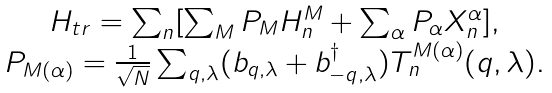<formula> <loc_0><loc_0><loc_500><loc_500>\begin{array} { c } H _ { t r } = \sum _ { n } [ \sum _ { M } P _ { M } H ^ { M } _ { n } + \sum _ { \alpha } P _ { \alpha } X ^ { \alpha } _ { n } ] , \\ P _ { M ( \alpha ) } = \frac { 1 } { \sqrt { N } } \sum _ { q , \lambda } ( b _ { q , \lambda } + b ^ { \dag } _ { - q , \lambda } ) T ^ { M ( \alpha ) } _ { n } ( q , \lambda ) . \end{array}</formula> 